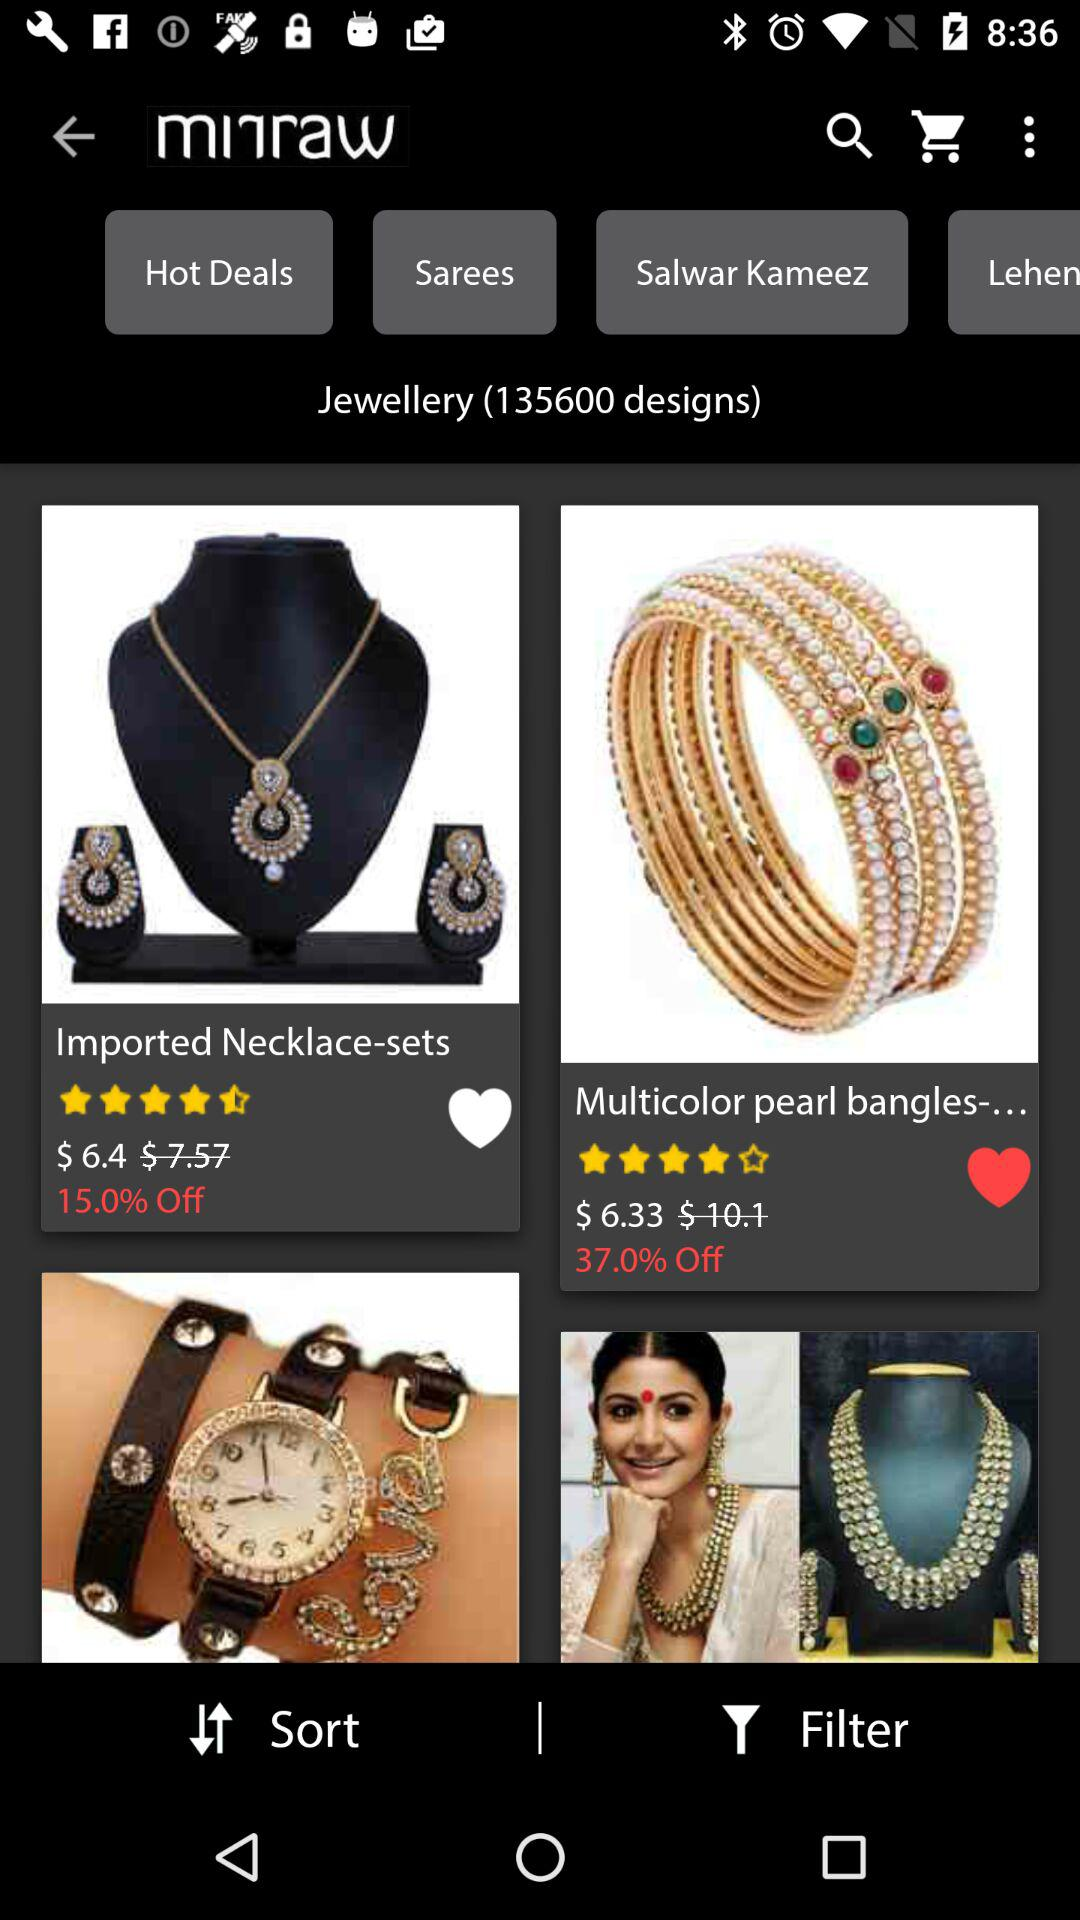What is the price of the bangles? The price of the bangles is $6.33. 